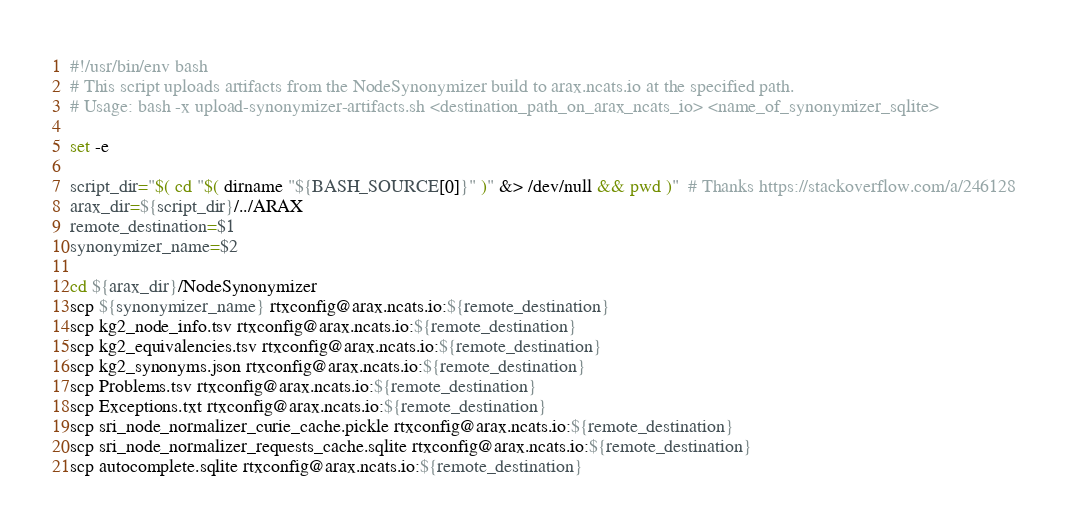<code> <loc_0><loc_0><loc_500><loc_500><_Bash_>#!/usr/bin/env bash
# This script uploads artifacts from the NodeSynonymizer build to arax.ncats.io at the specified path.
# Usage: bash -x upload-synonymizer-artifacts.sh <destination_path_on_arax_ncats_io> <name_of_synonymizer_sqlite>

set -e

script_dir="$( cd "$( dirname "${BASH_SOURCE[0]}" )" &> /dev/null && pwd )"  # Thanks https://stackoverflow.com/a/246128
arax_dir=${script_dir}/../ARAX
remote_destination=$1
synonymizer_name=$2

cd ${arax_dir}/NodeSynonymizer
scp ${synonymizer_name} rtxconfig@arax.ncats.io:${remote_destination}
scp kg2_node_info.tsv rtxconfig@arax.ncats.io:${remote_destination}
scp kg2_equivalencies.tsv rtxconfig@arax.ncats.io:${remote_destination}
scp kg2_synonyms.json rtxconfig@arax.ncats.io:${remote_destination}
scp Problems.tsv rtxconfig@arax.ncats.io:${remote_destination}
scp Exceptions.txt rtxconfig@arax.ncats.io:${remote_destination}
scp sri_node_normalizer_curie_cache.pickle rtxconfig@arax.ncats.io:${remote_destination}
scp sri_node_normalizer_requests_cache.sqlite rtxconfig@arax.ncats.io:${remote_destination}
scp autocomplete.sqlite rtxconfig@arax.ncats.io:${remote_destination}</code> 